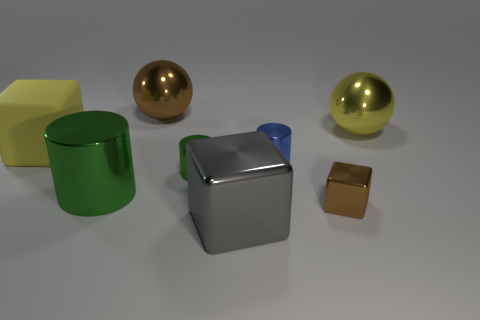Are there more small cylinders left of the blue shiny cylinder than brown metal spheres in front of the small metallic block?
Your answer should be compact. Yes. What is the size of the other metal cylinder that is the same color as the large cylinder?
Make the answer very short. Small. The matte block has what color?
Ensure brevity in your answer.  Yellow. The large shiny object that is right of the small green object and in front of the small green cylinder is what color?
Make the answer very short. Gray. There is a metallic object on the left side of the brown shiny object behind the brown metallic cube that is to the right of the large rubber block; what color is it?
Keep it short and to the point. Green. The shiny block that is the same size as the yellow matte block is what color?
Ensure brevity in your answer.  Gray. What shape is the big thing in front of the green shiny object left of the large sphere behind the large yellow sphere?
Provide a succinct answer. Cube. What is the shape of the metal thing that is the same color as the tiny cube?
Provide a succinct answer. Sphere. What number of objects are either large gray blocks or large objects behind the large yellow cube?
Your answer should be compact. 3. Is the size of the yellow object in front of the yellow metal thing the same as the tiny green metallic cylinder?
Offer a very short reply. No. 